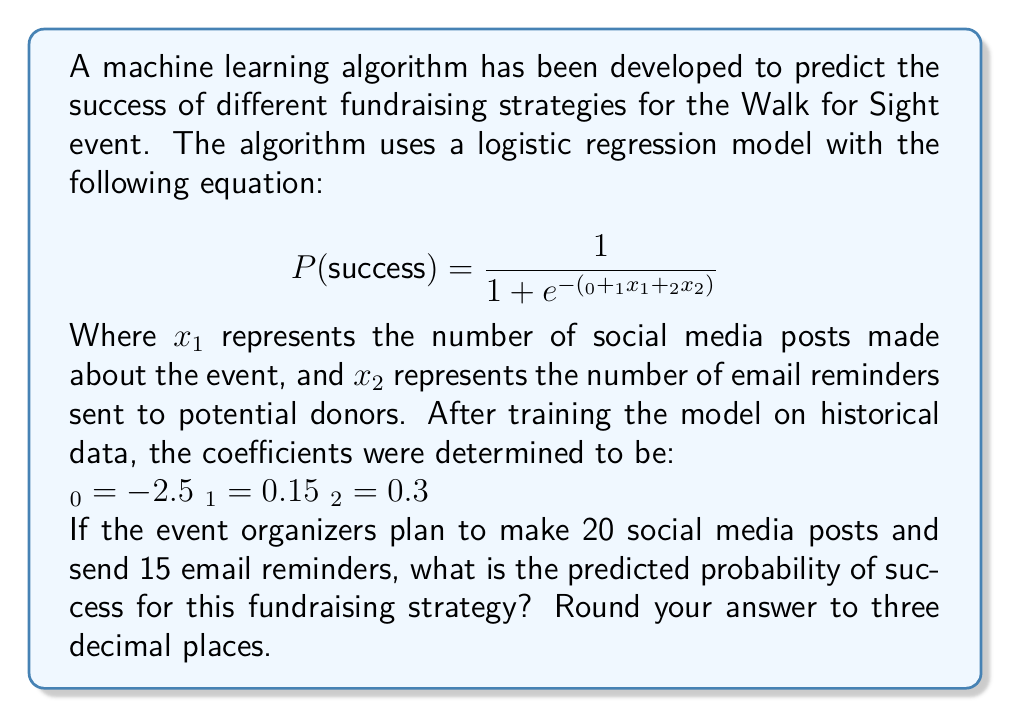Give your solution to this math problem. To solve this problem, we'll follow these steps:

1. Identify the given values:
   $β_0 = -2.5$
   $β_1 = 0.15$
   $β_2 = 0.3$
   $x_1 = 20$ (social media posts)
   $x_2 = 15$ (email reminders)

2. Substitute these values into the logistic regression equation:

   $$ P(success) = \frac{1}{1 + e^{-(β_0 + β_1x_1 + β_2x_2)}} $$

3. Calculate the value inside the exponential:
   $β_0 + β_1x_1 + β_2x_2 = -2.5 + 0.15(20) + 0.3(15)$
   $= -2.5 + 3 + 4.5$
   $= 5$

4. Now our equation looks like this:

   $$ P(success) = \frac{1}{1 + e^{-5}} $$

5. Calculate $e^{-5}$:
   $e^{-5} ≈ 0.00673795$ (using a calculator)

6. Substitute this value into the equation:

   $$ P(success) = \frac{1}{1 + 0.00673795} $$

7. Perform the division:
   $P(success) ≈ 0.993355$

8. Round to three decimal places:
   $P(success) ≈ 0.993$

Therefore, the predicted probability of success for this fundraising strategy is approximately 0.993 or 99.3%.
Answer: 0.993 